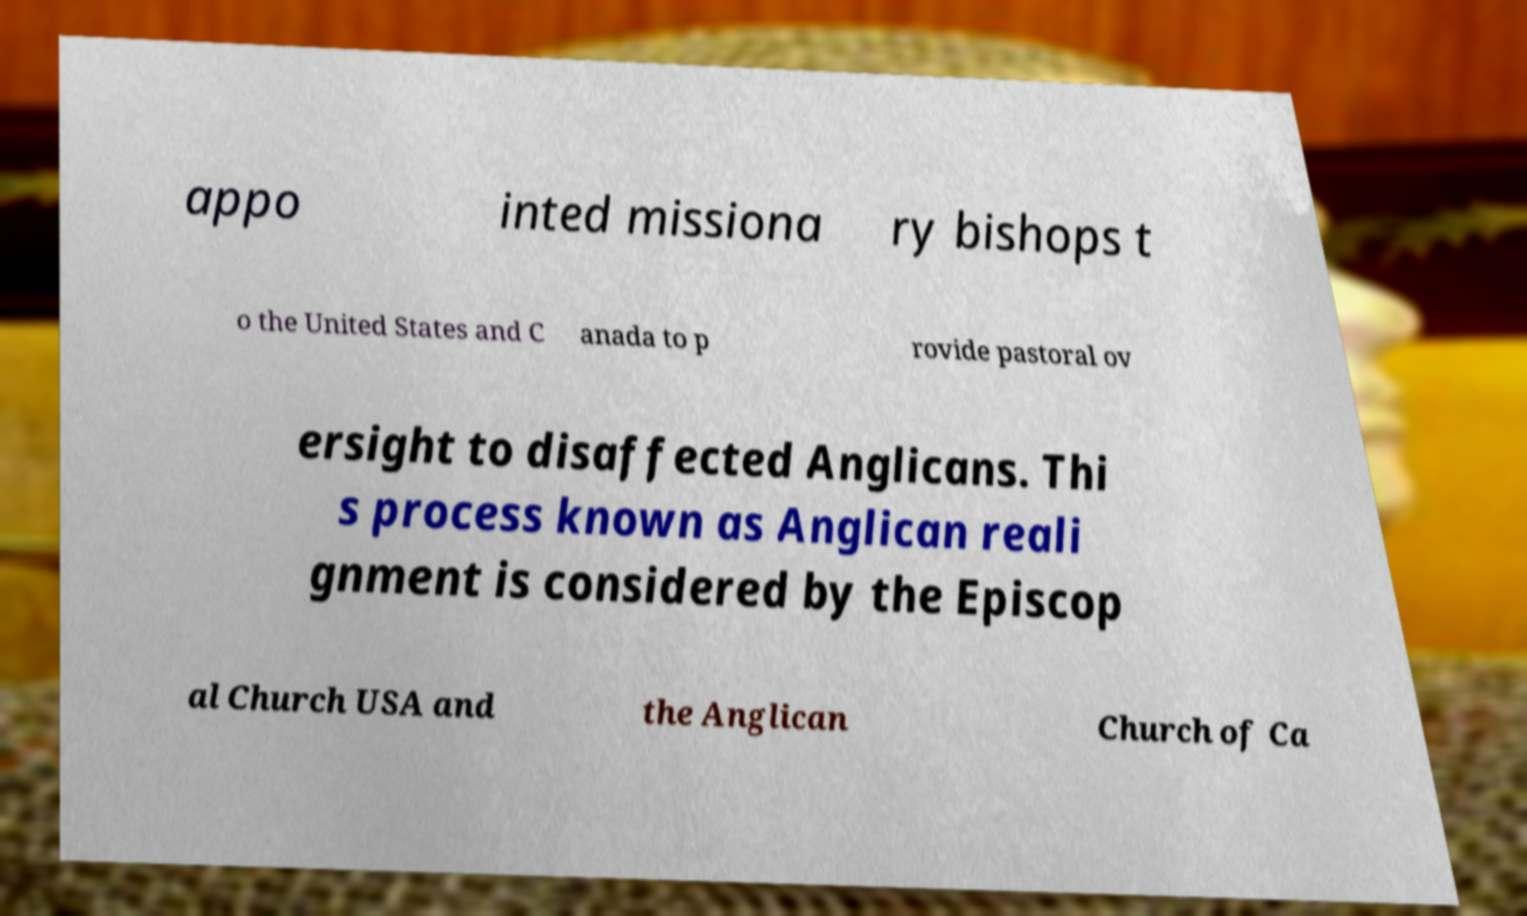Can you read and provide the text displayed in the image?This photo seems to have some interesting text. Can you extract and type it out for me? appo inted missiona ry bishops t o the United States and C anada to p rovide pastoral ov ersight to disaffected Anglicans. Thi s process known as Anglican reali gnment is considered by the Episcop al Church USA and the Anglican Church of Ca 